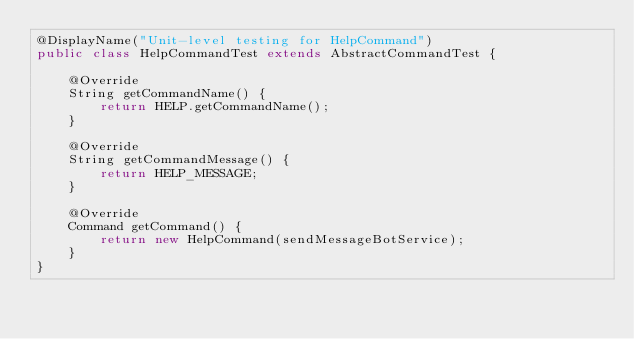Convert code to text. <code><loc_0><loc_0><loc_500><loc_500><_Java_>@DisplayName("Unit-level testing for HelpCommand")
public class HelpCommandTest extends AbstractCommandTest {

    @Override
    String getCommandName() {
        return HELP.getCommandName();
    }

    @Override
    String getCommandMessage() {
        return HELP_MESSAGE;
    }

    @Override
    Command getCommand() {
        return new HelpCommand(sendMessageBotService);
    }
}</code> 